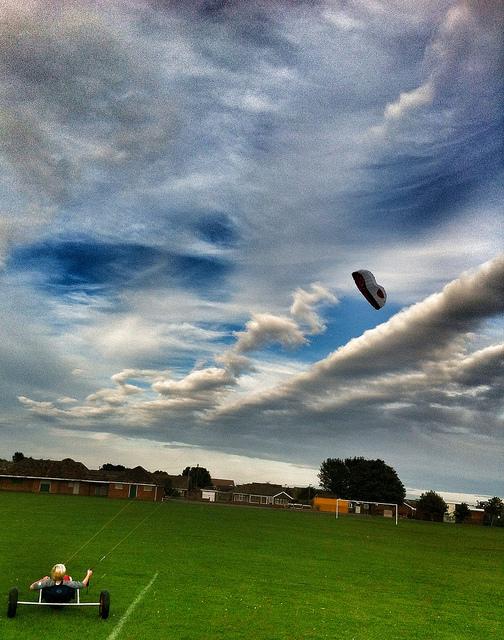Is there a tornado?
Keep it brief. No. Will the cart be towed by the sail?
Answer briefly. Yes. What color is the grass?
Keep it brief. Green. 